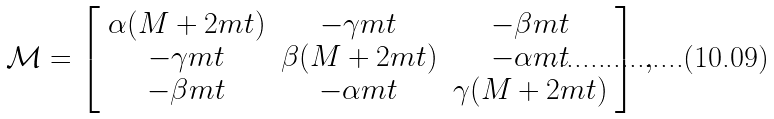<formula> <loc_0><loc_0><loc_500><loc_500>\mathcal { M } = \left [ \begin{array} { c c c } \alpha ( M + 2 m t ) & - \gamma m t & - \beta m t \\ - \gamma m t & \beta ( M + 2 m t ) & - \alpha m t \\ - \beta m t & - \alpha m t & \gamma ( M + 2 m t ) \end{array} \right ] \, ,</formula> 